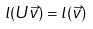Convert formula to latex. <formula><loc_0><loc_0><loc_500><loc_500>l ( U \vec { v } ) = l ( \vec { v } )</formula> 